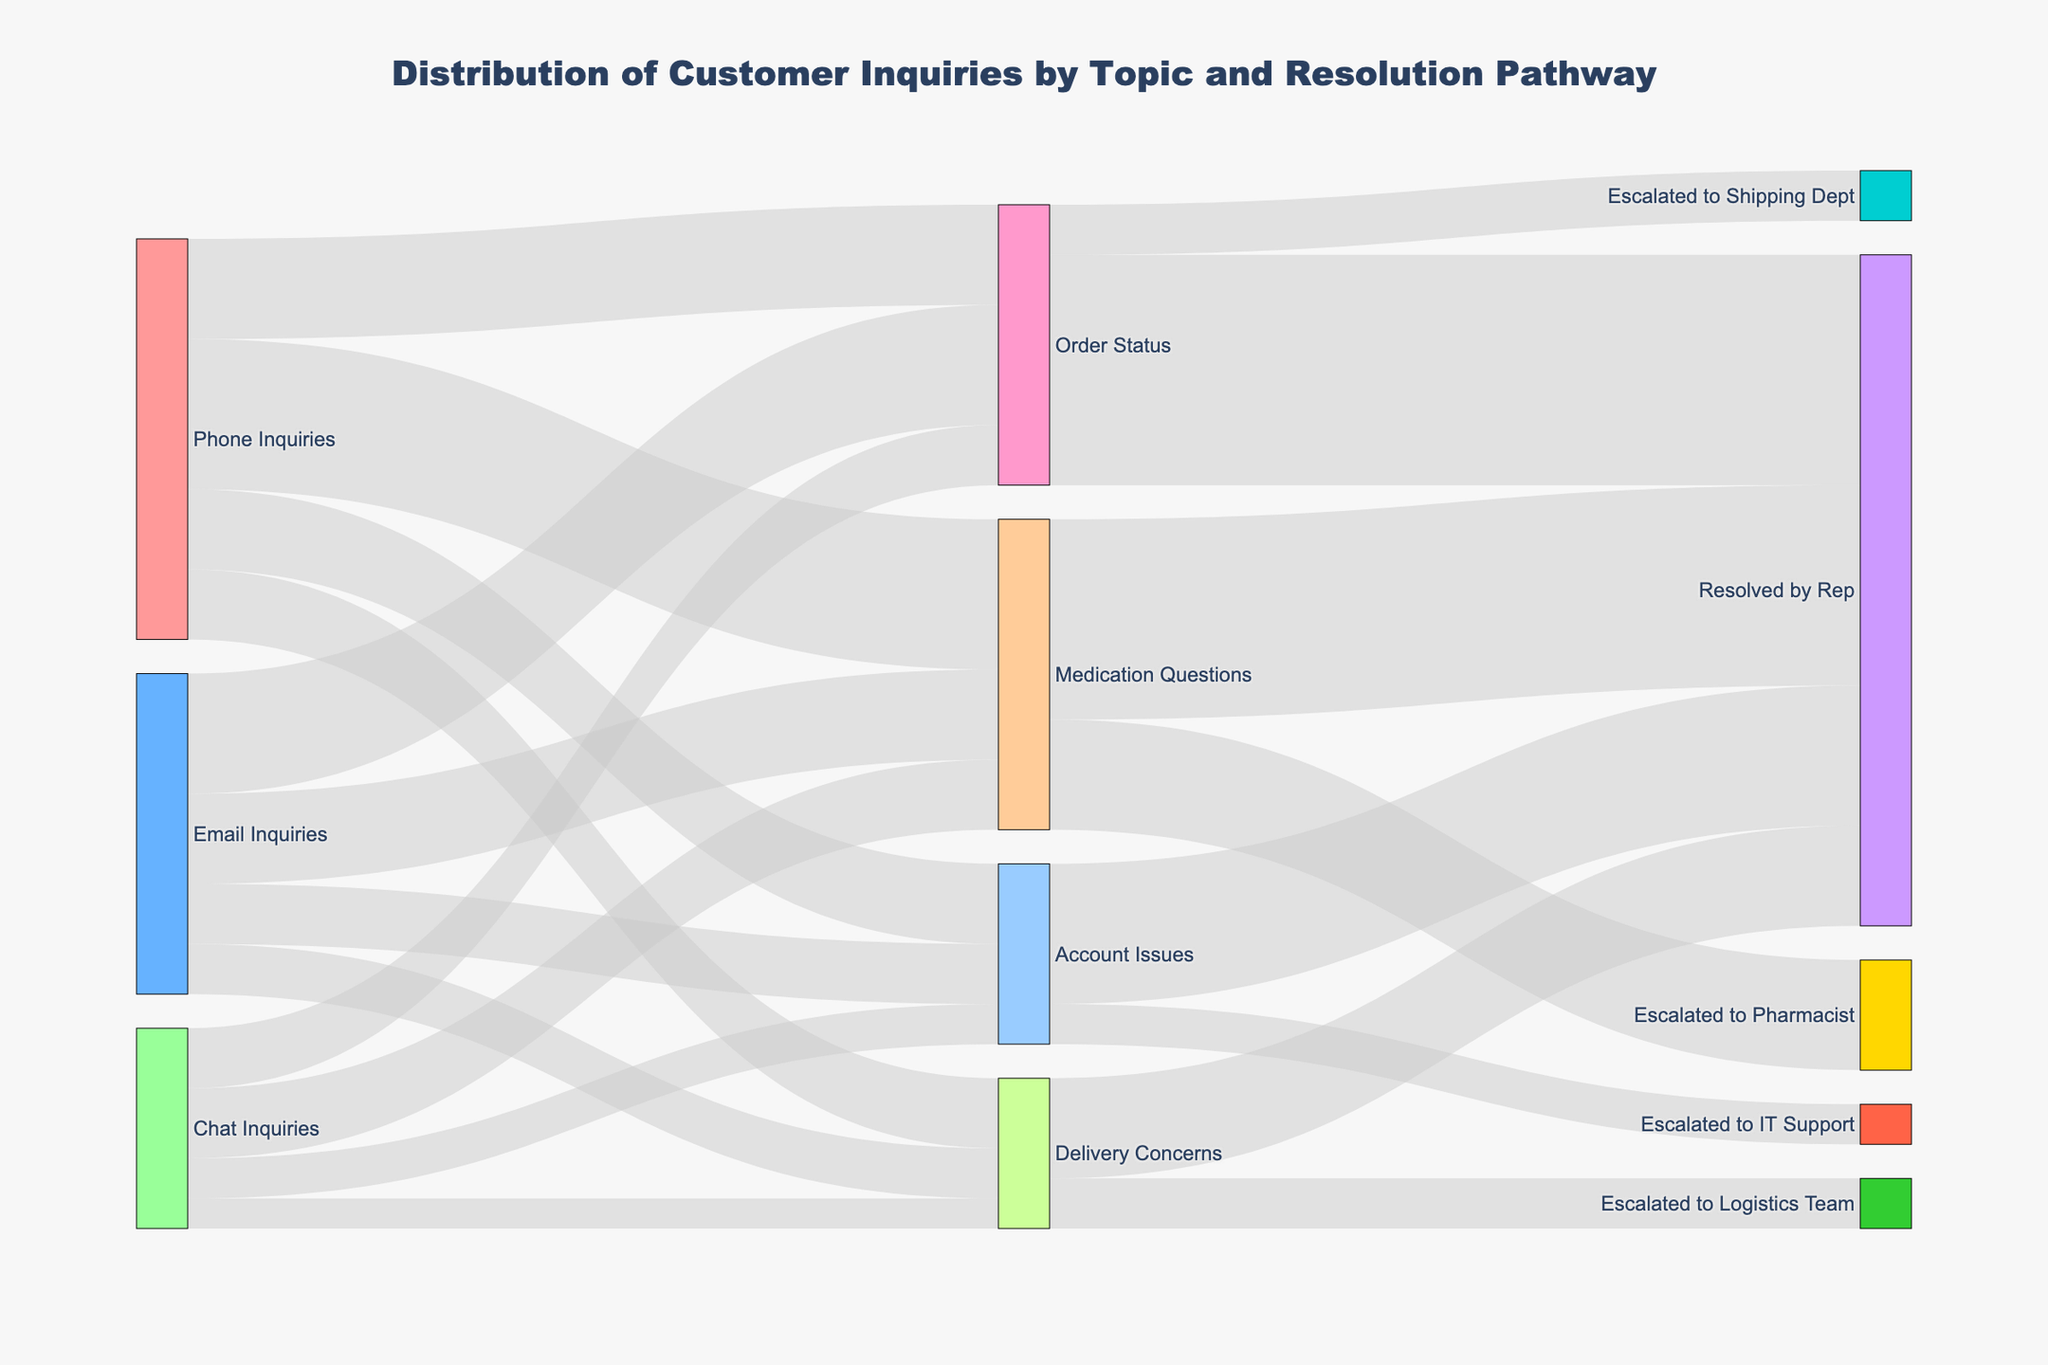What is the title of the Sankey diagram? The main title is typically found at the top of the Sankey diagram, and it describes the content and purpose of the figure.
Answer: Distribution of Customer Inquiries by Topic and Resolution Pathway What are the three main sources of customer inquiries in the Sankey diagram? By examining the labels on the left-hand side of the diagram, we can identify the main sources of inquiries.
Answer: Phone Inquiries, Email Inquiries, Chat Inquiries What colors represent 'Phone Inquiries' and 'Email Inquiries'? To determine the colors, look at the nodes labeled 'Phone Inquiries' and 'Email Inquiries' and observe their respective colors.
Answer: Red for Phone Inquiries, Blue for Email Inquiries How many inquiries were about 'Medication Questions'? Identify the flows leading to 'Medication Questions' and sum their values: 150 + 90 + 70 from the three sources.
Answer: 310 Which inquiry topic has the highest number of inquiries when combined from all sources? Sum the inquiries for each topic from all sources and identify the highest: 
- Medication Questions: 150 + 90 + 70 = 310 
- Order Status: 100 + 120 + 60 = 280 
- Account Issues: 80 + 60 + 40 = 180 
- Delivery Concerns: 70 + 50 + 30 = 150 
The highest sum is for Medication Questions.
Answer: Medication Questions What percentage of 'Order Status' inquiries are resolved by a representative? Determine the total 'Order Status' inquiries and how many are resolved by a representative, then calculate the percentage: 230 (resolved) out of 280 (total). 230/280 * 100 ≈ 82.14%
Answer: Approximately 82.14% How many inquiries are escalated to other departments besides being resolved by representatives? Identify all flows to departments other than 'Resolved by Rep' and sum them: 
- Escalated to Pharmacist: 110 
- Escalated to Shipping Dept: 50 
- Escalated to IT Support: 40 
- Escalated to Logistics Team: 50 
Sum: 110 + 50 + 40 + 50 = 250
Answer: 250 Which source generates the highest number of 'Account Issues' inquiries? Compare the number of 'Account Issues' inquiries from each source: 
- Phone Inquiries: 80 
- Email Inquiries: 60 
- Chat Inquiries: 40 
The highest number is from Phone Inquiries.
Answer: Phone Inquiries How do the 'resolved by rep' counts compare for 'Medication Questions' and 'Order Status' inquiries? Compare the values for 'Resolved by Rep' for both topics: 
- Medication Questions: 200 
- Order Status: 230 
230 is greater than 200.
Answer: Order Status inquiries are resolved more frequently by reps 